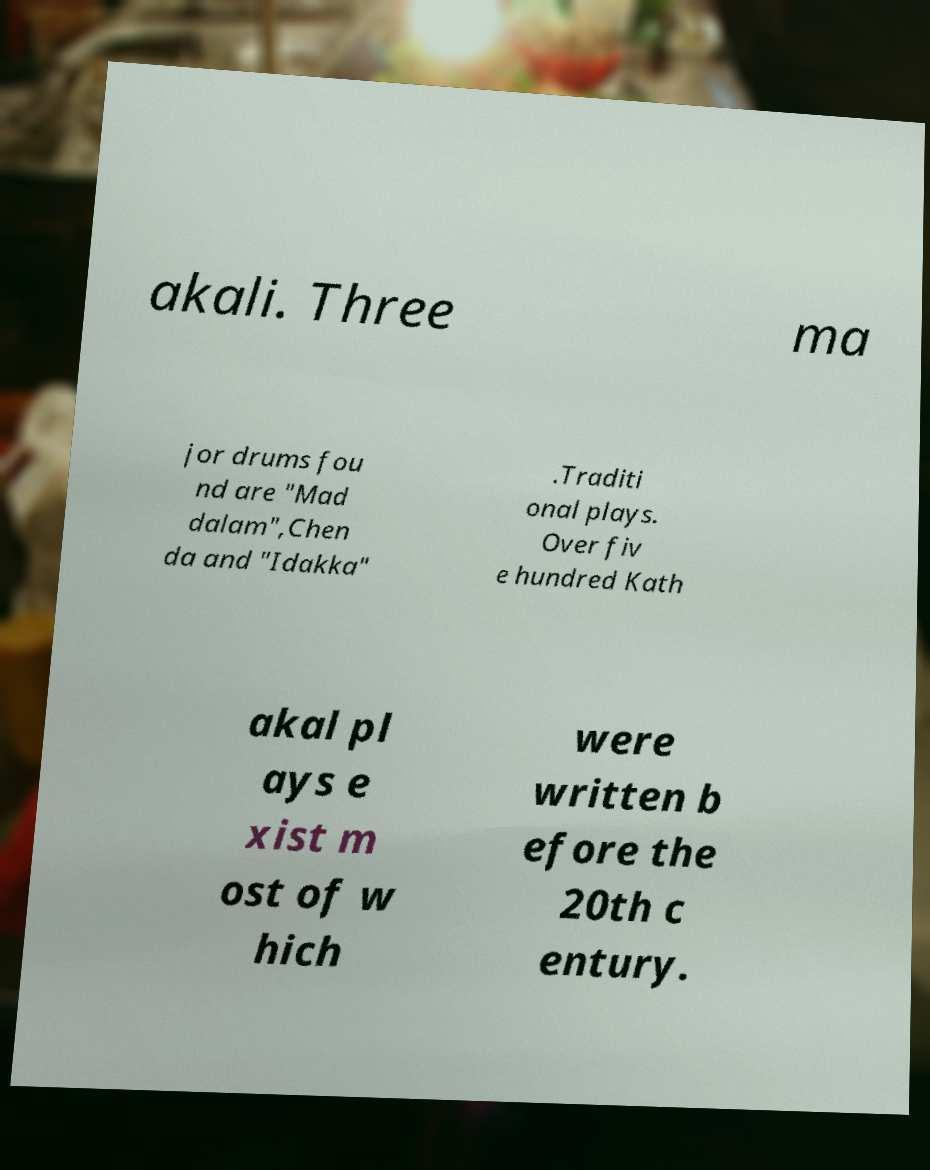Can you accurately transcribe the text from the provided image for me? akali. Three ma jor drums fou nd are "Mad dalam",Chen da and "Idakka" .Traditi onal plays. Over fiv e hundred Kath akal pl ays e xist m ost of w hich were written b efore the 20th c entury. 